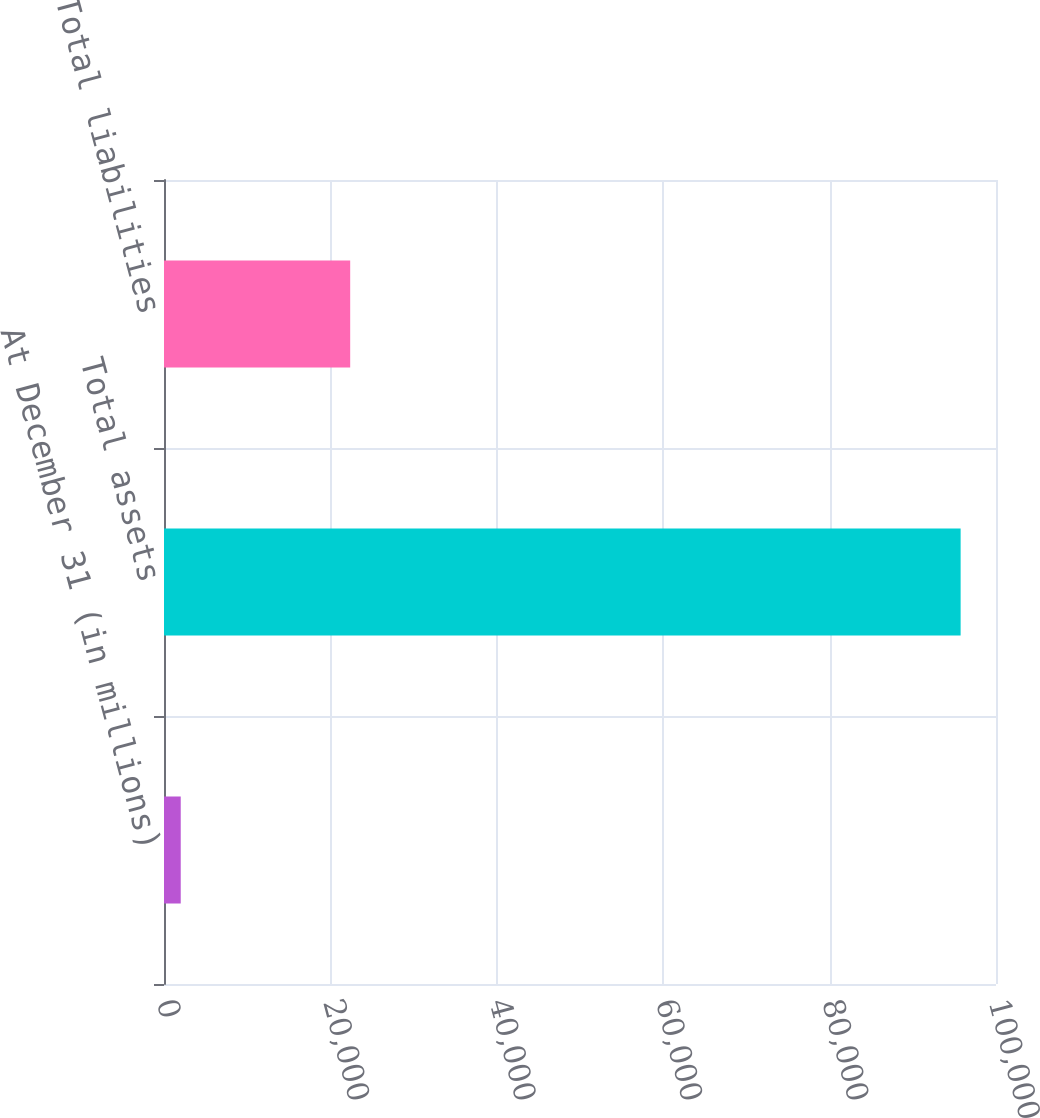<chart> <loc_0><loc_0><loc_500><loc_500><bar_chart><fcel>At December 31 (in millions)<fcel>Total assets<fcel>Total liabilities<nl><fcel>2011<fcel>95749<fcel>22379<nl></chart> 